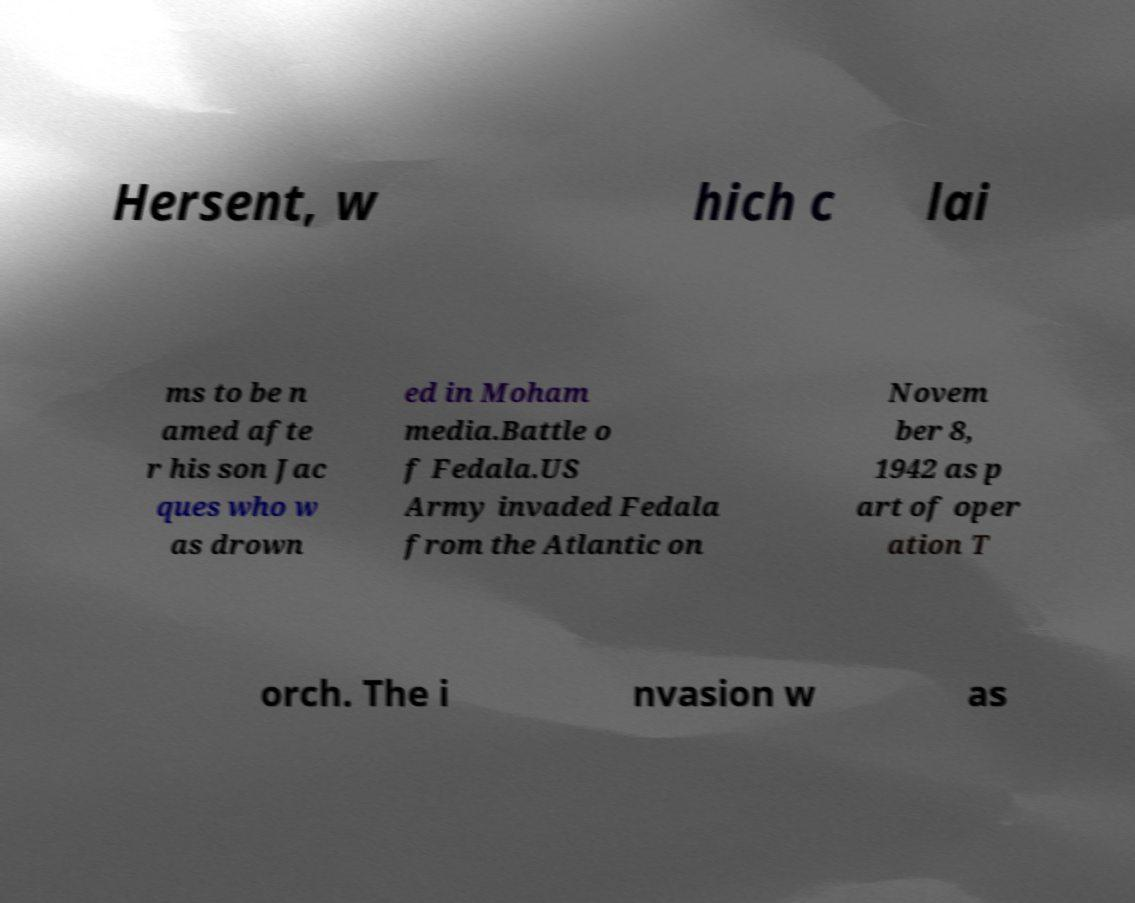Can you accurately transcribe the text from the provided image for me? Hersent, w hich c lai ms to be n amed afte r his son Jac ques who w as drown ed in Moham media.Battle o f Fedala.US Army invaded Fedala from the Atlantic on Novem ber 8, 1942 as p art of oper ation T orch. The i nvasion w as 